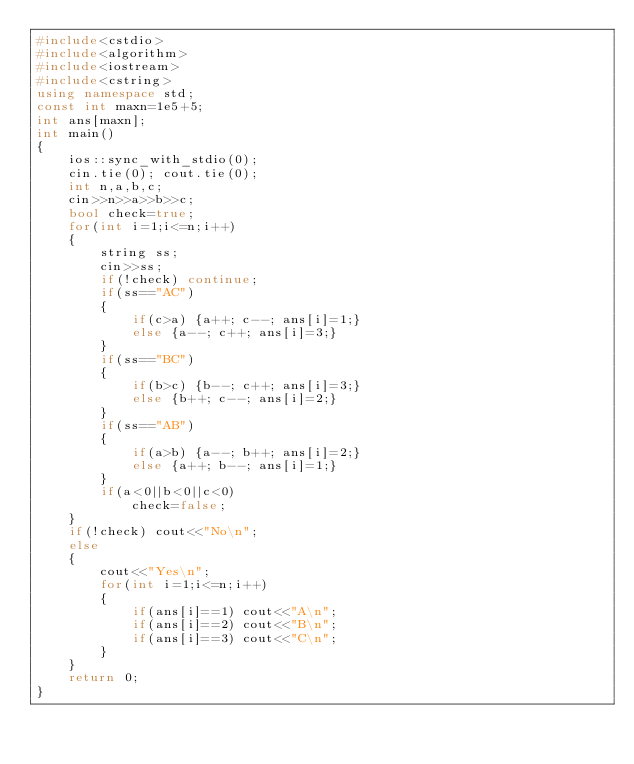<code> <loc_0><loc_0><loc_500><loc_500><_C++_>#include<cstdio>
#include<algorithm>
#include<iostream>
#include<cstring>
using namespace std;
const int maxn=1e5+5;
int ans[maxn];
int main()
{
    ios::sync_with_stdio(0);
    cin.tie(0); cout.tie(0);
    int n,a,b,c;
    cin>>n>>a>>b>>c;
    bool check=true;
    for(int i=1;i<=n;i++)
    {
        string ss;
        cin>>ss;
        if(!check) continue;
        if(ss=="AC")
        {
            if(c>a) {a++; c--; ans[i]=1;}
            else {a--; c++; ans[i]=3;}
        }
        if(ss=="BC")
        {
            if(b>c) {b--; c++; ans[i]=3;}
            else {b++; c--; ans[i]=2;}
        }
        if(ss=="AB")
        {
            if(a>b) {a--; b++; ans[i]=2;}
            else {a++; b--; ans[i]=1;}
        }
        if(a<0||b<0||c<0)
            check=false;
    }
    if(!check) cout<<"No\n";
    else
    {
        cout<<"Yes\n";
        for(int i=1;i<=n;i++)
        {
            if(ans[i]==1) cout<<"A\n";
            if(ans[i]==2) cout<<"B\n";
            if(ans[i]==3) cout<<"C\n";
        }
    }
    return 0;
}
</code> 